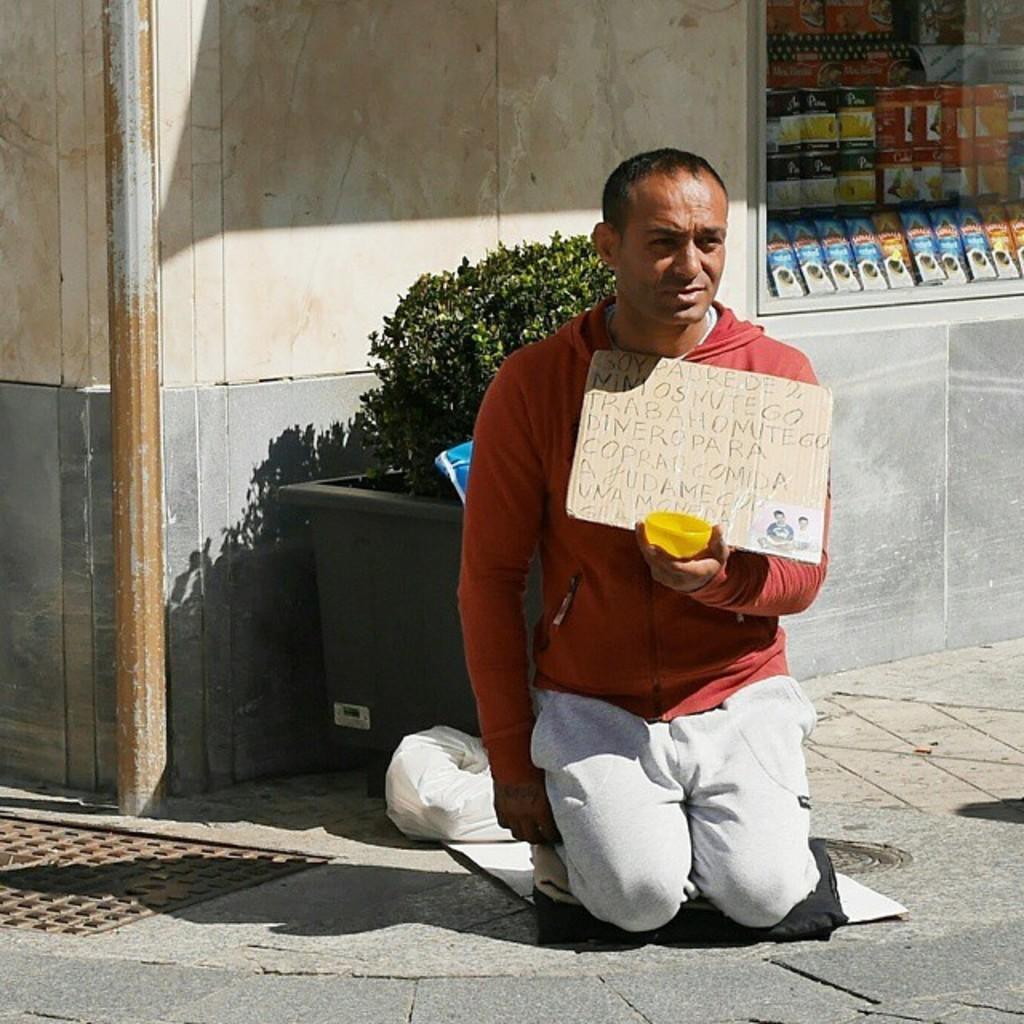Can you describe this image briefly? In this image we can see this person wearing an orange color sweater is sitting on the floor and holding a board and a bowl in his hands. In the background, we can see flower pot, wall and glass window through which we can see a few things. 